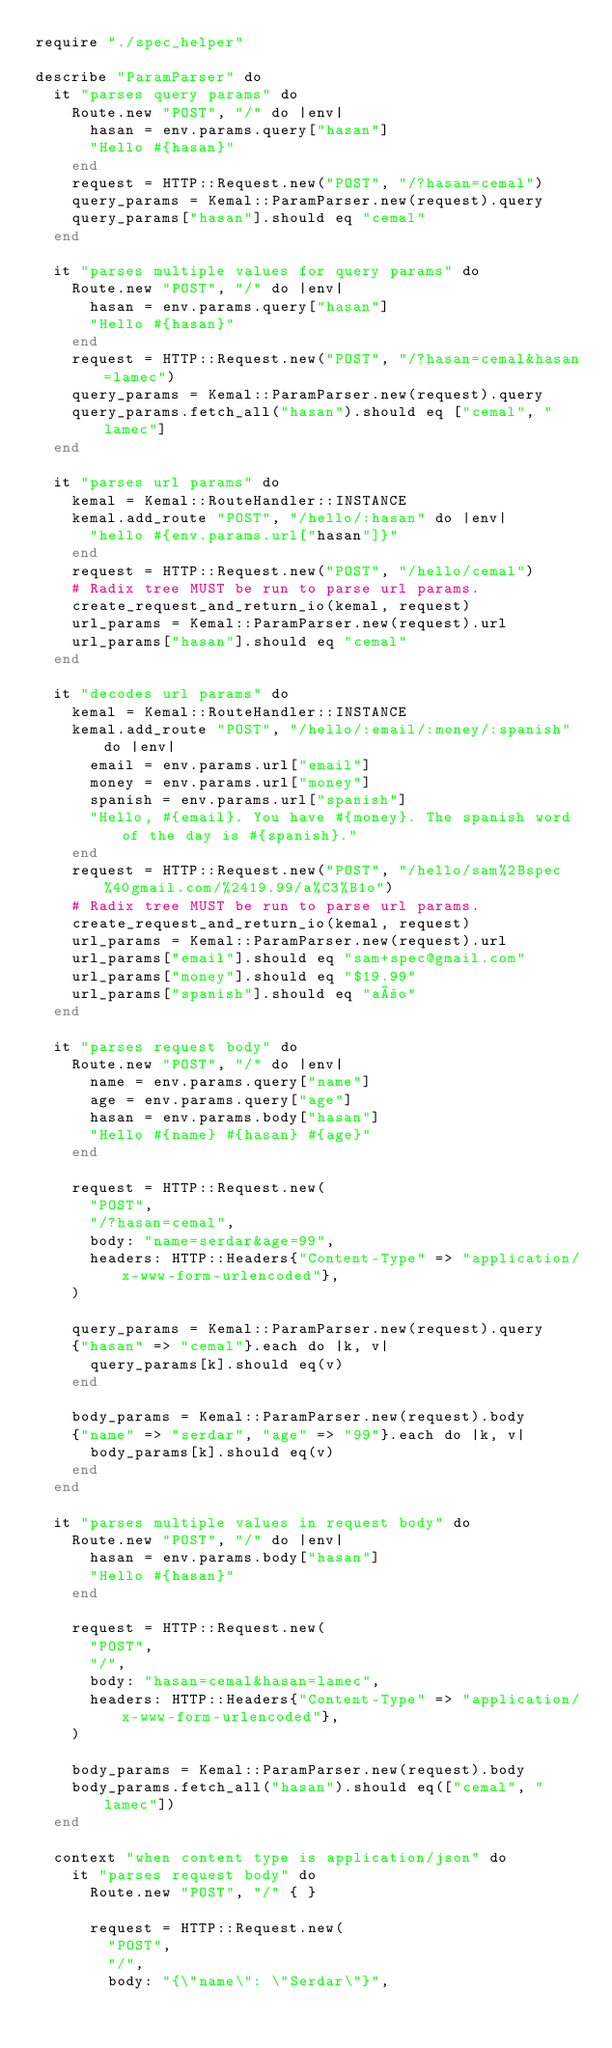<code> <loc_0><loc_0><loc_500><loc_500><_Crystal_>require "./spec_helper"

describe "ParamParser" do
  it "parses query params" do
    Route.new "POST", "/" do |env|
      hasan = env.params.query["hasan"]
      "Hello #{hasan}"
    end
    request = HTTP::Request.new("POST", "/?hasan=cemal")
    query_params = Kemal::ParamParser.new(request).query
    query_params["hasan"].should eq "cemal"
  end

  it "parses multiple values for query params" do
    Route.new "POST", "/" do |env|
      hasan = env.params.query["hasan"]
      "Hello #{hasan}"
    end
    request = HTTP::Request.new("POST", "/?hasan=cemal&hasan=lamec")
    query_params = Kemal::ParamParser.new(request).query
    query_params.fetch_all("hasan").should eq ["cemal", "lamec"]
  end

  it "parses url params" do
    kemal = Kemal::RouteHandler::INSTANCE
    kemal.add_route "POST", "/hello/:hasan" do |env|
      "hello #{env.params.url["hasan"]}"
    end
    request = HTTP::Request.new("POST", "/hello/cemal")
    # Radix tree MUST be run to parse url params.
    create_request_and_return_io(kemal, request)
    url_params = Kemal::ParamParser.new(request).url
    url_params["hasan"].should eq "cemal"
  end

  it "decodes url params" do
    kemal = Kemal::RouteHandler::INSTANCE
    kemal.add_route "POST", "/hello/:email/:money/:spanish" do |env|
      email = env.params.url["email"]
      money = env.params.url["money"]
      spanish = env.params.url["spanish"]
      "Hello, #{email}. You have #{money}. The spanish word of the day is #{spanish}."
    end
    request = HTTP::Request.new("POST", "/hello/sam%2Bspec%40gmail.com/%2419.99/a%C3%B1o")
    # Radix tree MUST be run to parse url params.
    create_request_and_return_io(kemal, request)
    url_params = Kemal::ParamParser.new(request).url
    url_params["email"].should eq "sam+spec@gmail.com"
    url_params["money"].should eq "$19.99"
    url_params["spanish"].should eq "año"
  end

  it "parses request body" do
    Route.new "POST", "/" do |env|
      name = env.params.query["name"]
      age = env.params.query["age"]
      hasan = env.params.body["hasan"]
      "Hello #{name} #{hasan} #{age}"
    end

    request = HTTP::Request.new(
      "POST",
      "/?hasan=cemal",
      body: "name=serdar&age=99",
      headers: HTTP::Headers{"Content-Type" => "application/x-www-form-urlencoded"},
    )

    query_params = Kemal::ParamParser.new(request).query
    {"hasan" => "cemal"}.each do |k, v|
      query_params[k].should eq(v)
    end

    body_params = Kemal::ParamParser.new(request).body
    {"name" => "serdar", "age" => "99"}.each do |k, v|
      body_params[k].should eq(v)
    end
  end

  it "parses multiple values in request body" do
    Route.new "POST", "/" do |env|
      hasan = env.params.body["hasan"]
      "Hello #{hasan}"
    end

    request = HTTP::Request.new(
      "POST",
      "/",
      body: "hasan=cemal&hasan=lamec",
      headers: HTTP::Headers{"Content-Type" => "application/x-www-form-urlencoded"},
    )

    body_params = Kemal::ParamParser.new(request).body
    body_params.fetch_all("hasan").should eq(["cemal", "lamec"])
  end

  context "when content type is application/json" do
    it "parses request body" do
      Route.new "POST", "/" { }

      request = HTTP::Request.new(
        "POST",
        "/",
        body: "{\"name\": \"Serdar\"}",</code> 